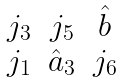<formula> <loc_0><loc_0><loc_500><loc_500>\begin{matrix} j _ { 3 } & j _ { 5 } & \hat { b } \\ j _ { 1 } & \hat { a } _ { 3 } & j _ { 6 } \end{matrix}</formula> 